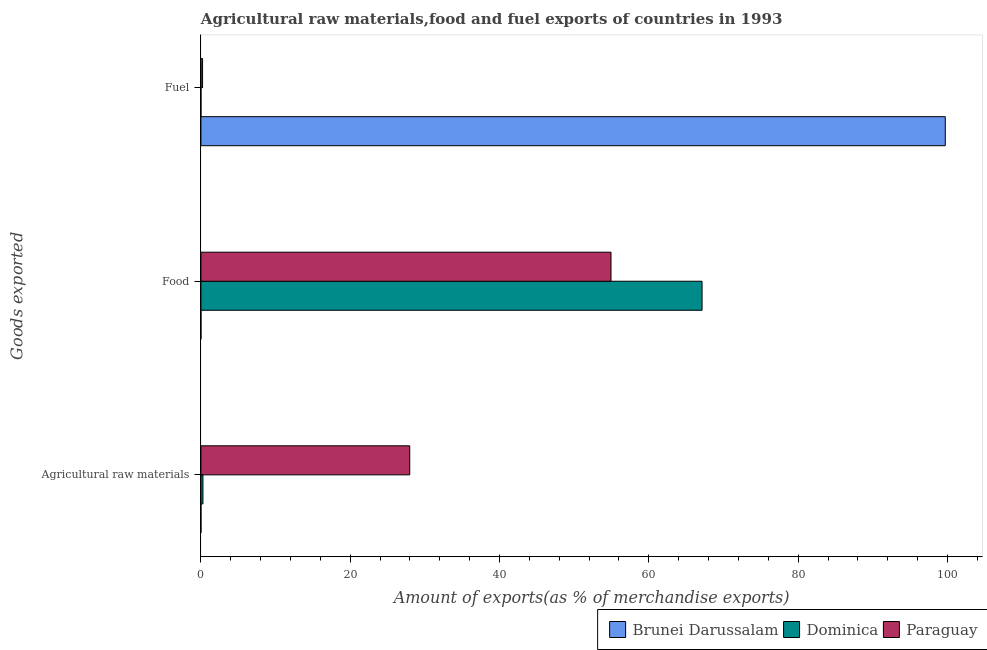How many different coloured bars are there?
Offer a terse response. 3. Are the number of bars per tick equal to the number of legend labels?
Offer a terse response. Yes. Are the number of bars on each tick of the Y-axis equal?
Your response must be concise. Yes. How many bars are there on the 1st tick from the top?
Keep it short and to the point. 3. How many bars are there on the 2nd tick from the bottom?
Your answer should be very brief. 3. What is the label of the 2nd group of bars from the top?
Your response must be concise. Food. What is the percentage of food exports in Paraguay?
Keep it short and to the point. 54.93. Across all countries, what is the maximum percentage of food exports?
Provide a succinct answer. 67.13. Across all countries, what is the minimum percentage of fuel exports?
Offer a very short reply. 0. In which country was the percentage of fuel exports maximum?
Offer a terse response. Brunei Darussalam. In which country was the percentage of fuel exports minimum?
Your answer should be very brief. Dominica. What is the total percentage of food exports in the graph?
Give a very brief answer. 122.06. What is the difference between the percentage of food exports in Paraguay and that in Brunei Darussalam?
Give a very brief answer. 54.93. What is the difference between the percentage of food exports in Paraguay and the percentage of raw materials exports in Dominica?
Provide a short and direct response. 54.66. What is the average percentage of raw materials exports per country?
Your response must be concise. 9.42. What is the difference between the percentage of fuel exports and percentage of food exports in Paraguay?
Give a very brief answer. -54.71. What is the ratio of the percentage of raw materials exports in Brunei Darussalam to that in Paraguay?
Ensure brevity in your answer.  2.810444337467936e-5. Is the percentage of fuel exports in Brunei Darussalam less than that in Dominica?
Ensure brevity in your answer.  No. What is the difference between the highest and the second highest percentage of fuel exports?
Your response must be concise. 99.49. What is the difference between the highest and the lowest percentage of raw materials exports?
Your answer should be very brief. 27.97. Is the sum of the percentage of food exports in Brunei Darussalam and Paraguay greater than the maximum percentage of fuel exports across all countries?
Offer a very short reply. No. What does the 2nd bar from the top in Agricultural raw materials represents?
Offer a terse response. Dominica. What does the 1st bar from the bottom in Food represents?
Your answer should be very brief. Brunei Darussalam. How many countries are there in the graph?
Your response must be concise. 3. What is the difference between two consecutive major ticks on the X-axis?
Offer a very short reply. 20. Does the graph contain any zero values?
Your response must be concise. No. Does the graph contain grids?
Offer a terse response. No. How many legend labels are there?
Your answer should be very brief. 3. How are the legend labels stacked?
Ensure brevity in your answer.  Horizontal. What is the title of the graph?
Provide a succinct answer. Agricultural raw materials,food and fuel exports of countries in 1993. Does "Guyana" appear as one of the legend labels in the graph?
Keep it short and to the point. No. What is the label or title of the X-axis?
Your answer should be compact. Amount of exports(as % of merchandise exports). What is the label or title of the Y-axis?
Keep it short and to the point. Goods exported. What is the Amount of exports(as % of merchandise exports) in Brunei Darussalam in Agricultural raw materials?
Provide a succinct answer. 0. What is the Amount of exports(as % of merchandise exports) of Dominica in Agricultural raw materials?
Give a very brief answer. 0.27. What is the Amount of exports(as % of merchandise exports) in Paraguay in Agricultural raw materials?
Keep it short and to the point. 27.97. What is the Amount of exports(as % of merchandise exports) in Brunei Darussalam in Food?
Your response must be concise. 0. What is the Amount of exports(as % of merchandise exports) of Dominica in Food?
Provide a succinct answer. 67.13. What is the Amount of exports(as % of merchandise exports) in Paraguay in Food?
Keep it short and to the point. 54.93. What is the Amount of exports(as % of merchandise exports) of Brunei Darussalam in Fuel?
Give a very brief answer. 99.71. What is the Amount of exports(as % of merchandise exports) of Dominica in Fuel?
Offer a terse response. 0. What is the Amount of exports(as % of merchandise exports) of Paraguay in Fuel?
Keep it short and to the point. 0.22. Across all Goods exported, what is the maximum Amount of exports(as % of merchandise exports) in Brunei Darussalam?
Offer a terse response. 99.71. Across all Goods exported, what is the maximum Amount of exports(as % of merchandise exports) in Dominica?
Give a very brief answer. 67.13. Across all Goods exported, what is the maximum Amount of exports(as % of merchandise exports) in Paraguay?
Give a very brief answer. 54.93. Across all Goods exported, what is the minimum Amount of exports(as % of merchandise exports) of Brunei Darussalam?
Offer a terse response. 0. Across all Goods exported, what is the minimum Amount of exports(as % of merchandise exports) in Dominica?
Keep it short and to the point. 0. Across all Goods exported, what is the minimum Amount of exports(as % of merchandise exports) of Paraguay?
Your answer should be compact. 0.22. What is the total Amount of exports(as % of merchandise exports) in Brunei Darussalam in the graph?
Keep it short and to the point. 99.71. What is the total Amount of exports(as % of merchandise exports) in Dominica in the graph?
Provide a succinct answer. 67.4. What is the total Amount of exports(as % of merchandise exports) in Paraguay in the graph?
Give a very brief answer. 83.13. What is the difference between the Amount of exports(as % of merchandise exports) of Dominica in Agricultural raw materials and that in Food?
Your answer should be compact. -66.86. What is the difference between the Amount of exports(as % of merchandise exports) in Paraguay in Agricultural raw materials and that in Food?
Offer a very short reply. -26.96. What is the difference between the Amount of exports(as % of merchandise exports) of Brunei Darussalam in Agricultural raw materials and that in Fuel?
Keep it short and to the point. -99.71. What is the difference between the Amount of exports(as % of merchandise exports) in Dominica in Agricultural raw materials and that in Fuel?
Give a very brief answer. 0.27. What is the difference between the Amount of exports(as % of merchandise exports) of Paraguay in Agricultural raw materials and that in Fuel?
Your response must be concise. 27.76. What is the difference between the Amount of exports(as % of merchandise exports) of Brunei Darussalam in Food and that in Fuel?
Your answer should be very brief. -99.71. What is the difference between the Amount of exports(as % of merchandise exports) of Dominica in Food and that in Fuel?
Ensure brevity in your answer.  67.13. What is the difference between the Amount of exports(as % of merchandise exports) in Paraguay in Food and that in Fuel?
Offer a very short reply. 54.71. What is the difference between the Amount of exports(as % of merchandise exports) of Brunei Darussalam in Agricultural raw materials and the Amount of exports(as % of merchandise exports) of Dominica in Food?
Your answer should be very brief. -67.13. What is the difference between the Amount of exports(as % of merchandise exports) in Brunei Darussalam in Agricultural raw materials and the Amount of exports(as % of merchandise exports) in Paraguay in Food?
Give a very brief answer. -54.93. What is the difference between the Amount of exports(as % of merchandise exports) in Dominica in Agricultural raw materials and the Amount of exports(as % of merchandise exports) in Paraguay in Food?
Your answer should be compact. -54.66. What is the difference between the Amount of exports(as % of merchandise exports) in Brunei Darussalam in Agricultural raw materials and the Amount of exports(as % of merchandise exports) in Dominica in Fuel?
Offer a terse response. 0. What is the difference between the Amount of exports(as % of merchandise exports) in Brunei Darussalam in Agricultural raw materials and the Amount of exports(as % of merchandise exports) in Paraguay in Fuel?
Your answer should be compact. -0.22. What is the difference between the Amount of exports(as % of merchandise exports) in Dominica in Agricultural raw materials and the Amount of exports(as % of merchandise exports) in Paraguay in Fuel?
Give a very brief answer. 0.05. What is the difference between the Amount of exports(as % of merchandise exports) in Brunei Darussalam in Food and the Amount of exports(as % of merchandise exports) in Paraguay in Fuel?
Your answer should be very brief. -0.22. What is the difference between the Amount of exports(as % of merchandise exports) in Dominica in Food and the Amount of exports(as % of merchandise exports) in Paraguay in Fuel?
Ensure brevity in your answer.  66.91. What is the average Amount of exports(as % of merchandise exports) of Brunei Darussalam per Goods exported?
Give a very brief answer. 33.24. What is the average Amount of exports(as % of merchandise exports) of Dominica per Goods exported?
Ensure brevity in your answer.  22.47. What is the average Amount of exports(as % of merchandise exports) in Paraguay per Goods exported?
Provide a succinct answer. 27.71. What is the difference between the Amount of exports(as % of merchandise exports) in Brunei Darussalam and Amount of exports(as % of merchandise exports) in Dominica in Agricultural raw materials?
Offer a very short reply. -0.27. What is the difference between the Amount of exports(as % of merchandise exports) of Brunei Darussalam and Amount of exports(as % of merchandise exports) of Paraguay in Agricultural raw materials?
Provide a succinct answer. -27.97. What is the difference between the Amount of exports(as % of merchandise exports) of Dominica and Amount of exports(as % of merchandise exports) of Paraguay in Agricultural raw materials?
Provide a succinct answer. -27.7. What is the difference between the Amount of exports(as % of merchandise exports) in Brunei Darussalam and Amount of exports(as % of merchandise exports) in Dominica in Food?
Offer a terse response. -67.13. What is the difference between the Amount of exports(as % of merchandise exports) of Brunei Darussalam and Amount of exports(as % of merchandise exports) of Paraguay in Food?
Provide a succinct answer. -54.93. What is the difference between the Amount of exports(as % of merchandise exports) in Dominica and Amount of exports(as % of merchandise exports) in Paraguay in Food?
Keep it short and to the point. 12.2. What is the difference between the Amount of exports(as % of merchandise exports) of Brunei Darussalam and Amount of exports(as % of merchandise exports) of Dominica in Fuel?
Ensure brevity in your answer.  99.71. What is the difference between the Amount of exports(as % of merchandise exports) of Brunei Darussalam and Amount of exports(as % of merchandise exports) of Paraguay in Fuel?
Your answer should be very brief. 99.49. What is the difference between the Amount of exports(as % of merchandise exports) in Dominica and Amount of exports(as % of merchandise exports) in Paraguay in Fuel?
Give a very brief answer. -0.22. What is the ratio of the Amount of exports(as % of merchandise exports) in Brunei Darussalam in Agricultural raw materials to that in Food?
Your answer should be very brief. 2.73. What is the ratio of the Amount of exports(as % of merchandise exports) of Dominica in Agricultural raw materials to that in Food?
Your answer should be very brief. 0. What is the ratio of the Amount of exports(as % of merchandise exports) of Paraguay in Agricultural raw materials to that in Food?
Keep it short and to the point. 0.51. What is the ratio of the Amount of exports(as % of merchandise exports) of Brunei Darussalam in Agricultural raw materials to that in Fuel?
Offer a very short reply. 0. What is the ratio of the Amount of exports(as % of merchandise exports) in Dominica in Agricultural raw materials to that in Fuel?
Your answer should be very brief. 1131.01. What is the ratio of the Amount of exports(as % of merchandise exports) of Paraguay in Agricultural raw materials to that in Fuel?
Offer a terse response. 127.77. What is the ratio of the Amount of exports(as % of merchandise exports) in Brunei Darussalam in Food to that in Fuel?
Make the answer very short. 0. What is the ratio of the Amount of exports(as % of merchandise exports) of Dominica in Food to that in Fuel?
Offer a terse response. 2.81e+05. What is the ratio of the Amount of exports(as % of merchandise exports) in Paraguay in Food to that in Fuel?
Provide a short and direct response. 250.9. What is the difference between the highest and the second highest Amount of exports(as % of merchandise exports) in Brunei Darussalam?
Keep it short and to the point. 99.71. What is the difference between the highest and the second highest Amount of exports(as % of merchandise exports) in Dominica?
Provide a short and direct response. 66.86. What is the difference between the highest and the second highest Amount of exports(as % of merchandise exports) of Paraguay?
Provide a short and direct response. 26.96. What is the difference between the highest and the lowest Amount of exports(as % of merchandise exports) of Brunei Darussalam?
Keep it short and to the point. 99.71. What is the difference between the highest and the lowest Amount of exports(as % of merchandise exports) of Dominica?
Offer a very short reply. 67.13. What is the difference between the highest and the lowest Amount of exports(as % of merchandise exports) of Paraguay?
Give a very brief answer. 54.71. 